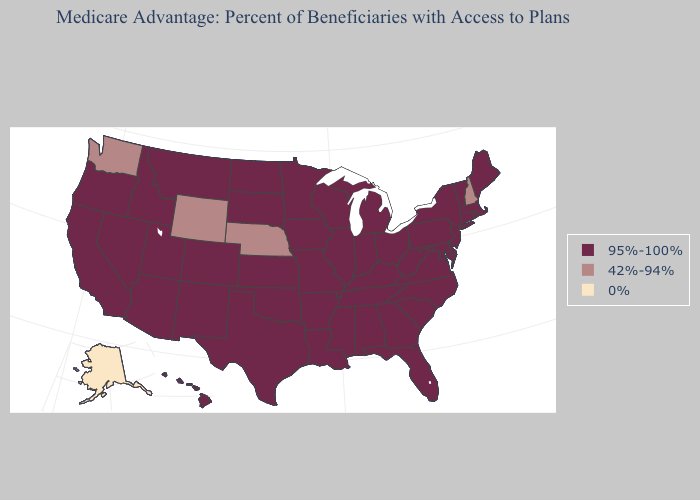How many symbols are there in the legend?
Concise answer only. 3. Name the states that have a value in the range 42%-94%?
Quick response, please. Nebraska, New Hampshire, Washington, Wyoming. What is the value of Alaska?
Write a very short answer. 0%. Does Wyoming have the highest value in the West?
Answer briefly. No. Does Idaho have the same value as Alaska?
Be succinct. No. What is the value of Oklahoma?
Give a very brief answer. 95%-100%. What is the value of Missouri?
Write a very short answer. 95%-100%. Does Minnesota have the highest value in the USA?
Quick response, please. Yes. Does Alaska have the lowest value in the USA?
Be succinct. Yes. Name the states that have a value in the range 42%-94%?
Keep it brief. Nebraska, New Hampshire, Washington, Wyoming. What is the value of New Hampshire?
Give a very brief answer. 42%-94%. Does Wyoming have the highest value in the USA?
Concise answer only. No. Does the map have missing data?
Short answer required. No. Among the states that border Arkansas , which have the lowest value?
Quick response, please. Louisiana, Missouri, Mississippi, Oklahoma, Tennessee, Texas. 